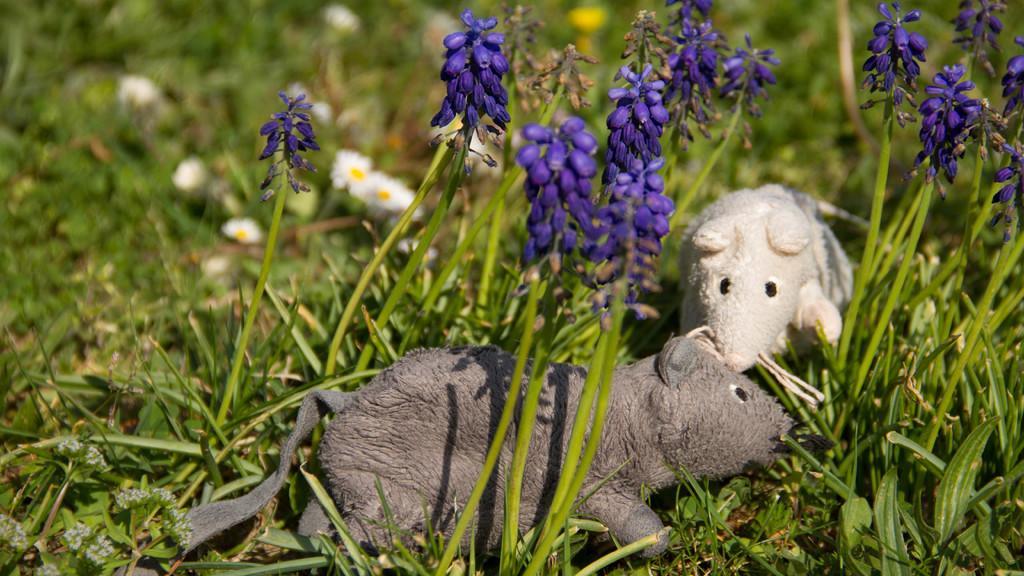How would you summarize this image in a sentence or two? In the center of the image there are depictions of rats. There are flower plants. There is grass. 